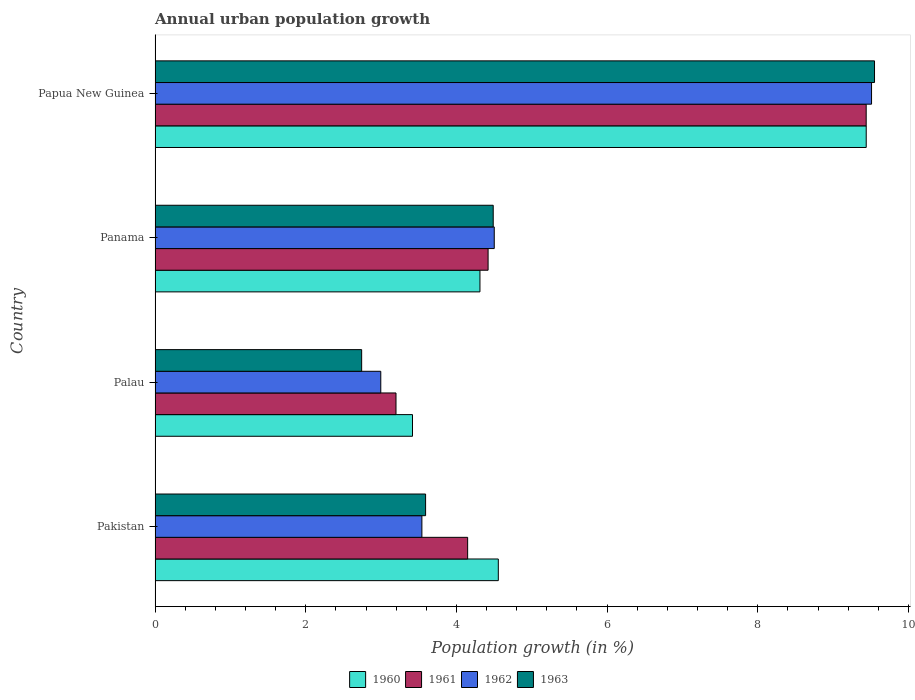What is the label of the 1st group of bars from the top?
Your response must be concise. Papua New Guinea. In how many cases, is the number of bars for a given country not equal to the number of legend labels?
Your answer should be compact. 0. What is the percentage of urban population growth in 1961 in Palau?
Make the answer very short. 3.2. Across all countries, what is the maximum percentage of urban population growth in 1960?
Provide a short and direct response. 9.44. Across all countries, what is the minimum percentage of urban population growth in 1961?
Make the answer very short. 3.2. In which country was the percentage of urban population growth in 1961 maximum?
Give a very brief answer. Papua New Guinea. In which country was the percentage of urban population growth in 1963 minimum?
Your answer should be compact. Palau. What is the total percentage of urban population growth in 1963 in the graph?
Offer a terse response. 20.37. What is the difference between the percentage of urban population growth in 1960 in Pakistan and that in Panama?
Offer a very short reply. 0.24. What is the difference between the percentage of urban population growth in 1962 in Papua New Guinea and the percentage of urban population growth in 1960 in Pakistan?
Your answer should be very brief. 4.95. What is the average percentage of urban population growth in 1961 per country?
Offer a very short reply. 5.3. What is the difference between the percentage of urban population growth in 1963 and percentage of urban population growth in 1961 in Palau?
Provide a succinct answer. -0.46. What is the ratio of the percentage of urban population growth in 1962 in Palau to that in Panama?
Keep it short and to the point. 0.67. Is the percentage of urban population growth in 1963 in Palau less than that in Papua New Guinea?
Keep it short and to the point. Yes. What is the difference between the highest and the second highest percentage of urban population growth in 1963?
Provide a short and direct response. 5.06. What is the difference between the highest and the lowest percentage of urban population growth in 1963?
Offer a terse response. 6.81. In how many countries, is the percentage of urban population growth in 1962 greater than the average percentage of urban population growth in 1962 taken over all countries?
Offer a very short reply. 1. Is the sum of the percentage of urban population growth in 1960 in Palau and Panama greater than the maximum percentage of urban population growth in 1962 across all countries?
Your answer should be very brief. No. Is it the case that in every country, the sum of the percentage of urban population growth in 1963 and percentage of urban population growth in 1961 is greater than the sum of percentage of urban population growth in 1960 and percentage of urban population growth in 1962?
Keep it short and to the point. No. What does the 1st bar from the top in Papua New Guinea represents?
Make the answer very short. 1963. What does the 2nd bar from the bottom in Papua New Guinea represents?
Your answer should be compact. 1961. How many countries are there in the graph?
Offer a terse response. 4. What is the difference between two consecutive major ticks on the X-axis?
Make the answer very short. 2. Are the values on the major ticks of X-axis written in scientific E-notation?
Keep it short and to the point. No. Does the graph contain any zero values?
Offer a very short reply. No. Does the graph contain grids?
Provide a succinct answer. No. How many legend labels are there?
Your answer should be very brief. 4. What is the title of the graph?
Offer a very short reply. Annual urban population growth. What is the label or title of the X-axis?
Make the answer very short. Population growth (in %). What is the label or title of the Y-axis?
Provide a short and direct response. Country. What is the Population growth (in %) in 1960 in Pakistan?
Provide a short and direct response. 4.56. What is the Population growth (in %) in 1961 in Pakistan?
Offer a very short reply. 4.15. What is the Population growth (in %) in 1962 in Pakistan?
Give a very brief answer. 3.54. What is the Population growth (in %) of 1963 in Pakistan?
Provide a short and direct response. 3.59. What is the Population growth (in %) of 1960 in Palau?
Give a very brief answer. 3.42. What is the Population growth (in %) of 1961 in Palau?
Make the answer very short. 3.2. What is the Population growth (in %) of 1962 in Palau?
Give a very brief answer. 3. What is the Population growth (in %) in 1963 in Palau?
Give a very brief answer. 2.74. What is the Population growth (in %) in 1960 in Panama?
Give a very brief answer. 4.31. What is the Population growth (in %) in 1961 in Panama?
Offer a very short reply. 4.42. What is the Population growth (in %) in 1962 in Panama?
Your answer should be very brief. 4.5. What is the Population growth (in %) in 1963 in Panama?
Your answer should be compact. 4.49. What is the Population growth (in %) of 1960 in Papua New Guinea?
Give a very brief answer. 9.44. What is the Population growth (in %) of 1961 in Papua New Guinea?
Your response must be concise. 9.44. What is the Population growth (in %) in 1962 in Papua New Guinea?
Your answer should be compact. 9.51. What is the Population growth (in %) in 1963 in Papua New Guinea?
Keep it short and to the point. 9.55. Across all countries, what is the maximum Population growth (in %) in 1960?
Your answer should be very brief. 9.44. Across all countries, what is the maximum Population growth (in %) in 1961?
Offer a terse response. 9.44. Across all countries, what is the maximum Population growth (in %) of 1962?
Offer a very short reply. 9.51. Across all countries, what is the maximum Population growth (in %) in 1963?
Your response must be concise. 9.55. Across all countries, what is the minimum Population growth (in %) of 1960?
Give a very brief answer. 3.42. Across all countries, what is the minimum Population growth (in %) of 1961?
Provide a short and direct response. 3.2. Across all countries, what is the minimum Population growth (in %) of 1962?
Give a very brief answer. 3. Across all countries, what is the minimum Population growth (in %) in 1963?
Your response must be concise. 2.74. What is the total Population growth (in %) of 1960 in the graph?
Give a very brief answer. 21.73. What is the total Population growth (in %) in 1961 in the graph?
Your response must be concise. 21.21. What is the total Population growth (in %) of 1962 in the graph?
Ensure brevity in your answer.  20.55. What is the total Population growth (in %) of 1963 in the graph?
Your response must be concise. 20.37. What is the difference between the Population growth (in %) in 1960 in Pakistan and that in Palau?
Ensure brevity in your answer.  1.14. What is the difference between the Population growth (in %) of 1961 in Pakistan and that in Palau?
Your response must be concise. 0.95. What is the difference between the Population growth (in %) of 1962 in Pakistan and that in Palau?
Your response must be concise. 0.55. What is the difference between the Population growth (in %) in 1963 in Pakistan and that in Palau?
Your response must be concise. 0.85. What is the difference between the Population growth (in %) in 1960 in Pakistan and that in Panama?
Ensure brevity in your answer.  0.24. What is the difference between the Population growth (in %) of 1961 in Pakistan and that in Panama?
Offer a very short reply. -0.27. What is the difference between the Population growth (in %) in 1962 in Pakistan and that in Panama?
Your answer should be compact. -0.96. What is the difference between the Population growth (in %) of 1963 in Pakistan and that in Panama?
Your answer should be very brief. -0.9. What is the difference between the Population growth (in %) in 1960 in Pakistan and that in Papua New Guinea?
Provide a short and direct response. -4.88. What is the difference between the Population growth (in %) in 1961 in Pakistan and that in Papua New Guinea?
Your answer should be compact. -5.29. What is the difference between the Population growth (in %) of 1962 in Pakistan and that in Papua New Guinea?
Your answer should be compact. -5.97. What is the difference between the Population growth (in %) in 1963 in Pakistan and that in Papua New Guinea?
Provide a short and direct response. -5.96. What is the difference between the Population growth (in %) of 1960 in Palau and that in Panama?
Ensure brevity in your answer.  -0.9. What is the difference between the Population growth (in %) in 1961 in Palau and that in Panama?
Offer a very short reply. -1.22. What is the difference between the Population growth (in %) of 1962 in Palau and that in Panama?
Your answer should be compact. -1.51. What is the difference between the Population growth (in %) in 1963 in Palau and that in Panama?
Provide a short and direct response. -1.75. What is the difference between the Population growth (in %) in 1960 in Palau and that in Papua New Guinea?
Ensure brevity in your answer.  -6.02. What is the difference between the Population growth (in %) of 1961 in Palau and that in Papua New Guinea?
Provide a succinct answer. -6.24. What is the difference between the Population growth (in %) in 1962 in Palau and that in Papua New Guinea?
Make the answer very short. -6.51. What is the difference between the Population growth (in %) of 1963 in Palau and that in Papua New Guinea?
Your answer should be very brief. -6.81. What is the difference between the Population growth (in %) of 1960 in Panama and that in Papua New Guinea?
Offer a terse response. -5.13. What is the difference between the Population growth (in %) of 1961 in Panama and that in Papua New Guinea?
Make the answer very short. -5.02. What is the difference between the Population growth (in %) in 1962 in Panama and that in Papua New Guinea?
Your answer should be very brief. -5.01. What is the difference between the Population growth (in %) of 1963 in Panama and that in Papua New Guinea?
Your response must be concise. -5.06. What is the difference between the Population growth (in %) of 1960 in Pakistan and the Population growth (in %) of 1961 in Palau?
Your response must be concise. 1.36. What is the difference between the Population growth (in %) in 1960 in Pakistan and the Population growth (in %) in 1962 in Palau?
Make the answer very short. 1.56. What is the difference between the Population growth (in %) in 1960 in Pakistan and the Population growth (in %) in 1963 in Palau?
Make the answer very short. 1.81. What is the difference between the Population growth (in %) of 1961 in Pakistan and the Population growth (in %) of 1962 in Palau?
Provide a short and direct response. 1.15. What is the difference between the Population growth (in %) in 1961 in Pakistan and the Population growth (in %) in 1963 in Palau?
Keep it short and to the point. 1.41. What is the difference between the Population growth (in %) in 1962 in Pakistan and the Population growth (in %) in 1963 in Palau?
Your answer should be compact. 0.8. What is the difference between the Population growth (in %) of 1960 in Pakistan and the Population growth (in %) of 1961 in Panama?
Offer a terse response. 0.14. What is the difference between the Population growth (in %) in 1960 in Pakistan and the Population growth (in %) in 1962 in Panama?
Your answer should be compact. 0.05. What is the difference between the Population growth (in %) in 1960 in Pakistan and the Population growth (in %) in 1963 in Panama?
Give a very brief answer. 0.07. What is the difference between the Population growth (in %) in 1961 in Pakistan and the Population growth (in %) in 1962 in Panama?
Offer a very short reply. -0.35. What is the difference between the Population growth (in %) in 1961 in Pakistan and the Population growth (in %) in 1963 in Panama?
Ensure brevity in your answer.  -0.34. What is the difference between the Population growth (in %) in 1962 in Pakistan and the Population growth (in %) in 1963 in Panama?
Offer a terse response. -0.95. What is the difference between the Population growth (in %) in 1960 in Pakistan and the Population growth (in %) in 1961 in Papua New Guinea?
Give a very brief answer. -4.88. What is the difference between the Population growth (in %) of 1960 in Pakistan and the Population growth (in %) of 1962 in Papua New Guinea?
Provide a succinct answer. -4.95. What is the difference between the Population growth (in %) of 1960 in Pakistan and the Population growth (in %) of 1963 in Papua New Guinea?
Make the answer very short. -4.99. What is the difference between the Population growth (in %) of 1961 in Pakistan and the Population growth (in %) of 1962 in Papua New Guinea?
Keep it short and to the point. -5.36. What is the difference between the Population growth (in %) in 1961 in Pakistan and the Population growth (in %) in 1963 in Papua New Guinea?
Offer a very short reply. -5.4. What is the difference between the Population growth (in %) of 1962 in Pakistan and the Population growth (in %) of 1963 in Papua New Guinea?
Ensure brevity in your answer.  -6.01. What is the difference between the Population growth (in %) of 1960 in Palau and the Population growth (in %) of 1961 in Panama?
Provide a succinct answer. -1. What is the difference between the Population growth (in %) in 1960 in Palau and the Population growth (in %) in 1962 in Panama?
Ensure brevity in your answer.  -1.09. What is the difference between the Population growth (in %) in 1960 in Palau and the Population growth (in %) in 1963 in Panama?
Your answer should be compact. -1.07. What is the difference between the Population growth (in %) of 1961 in Palau and the Population growth (in %) of 1962 in Panama?
Provide a succinct answer. -1.3. What is the difference between the Population growth (in %) in 1961 in Palau and the Population growth (in %) in 1963 in Panama?
Make the answer very short. -1.29. What is the difference between the Population growth (in %) in 1962 in Palau and the Population growth (in %) in 1963 in Panama?
Give a very brief answer. -1.49. What is the difference between the Population growth (in %) of 1960 in Palau and the Population growth (in %) of 1961 in Papua New Guinea?
Provide a short and direct response. -6.02. What is the difference between the Population growth (in %) in 1960 in Palau and the Population growth (in %) in 1962 in Papua New Guinea?
Offer a terse response. -6.09. What is the difference between the Population growth (in %) in 1960 in Palau and the Population growth (in %) in 1963 in Papua New Guinea?
Provide a succinct answer. -6.13. What is the difference between the Population growth (in %) in 1961 in Palau and the Population growth (in %) in 1962 in Papua New Guinea?
Your answer should be very brief. -6.31. What is the difference between the Population growth (in %) in 1961 in Palau and the Population growth (in %) in 1963 in Papua New Guinea?
Ensure brevity in your answer.  -6.35. What is the difference between the Population growth (in %) in 1962 in Palau and the Population growth (in %) in 1963 in Papua New Guinea?
Keep it short and to the point. -6.55. What is the difference between the Population growth (in %) in 1960 in Panama and the Population growth (in %) in 1961 in Papua New Guinea?
Your answer should be very brief. -5.13. What is the difference between the Population growth (in %) of 1960 in Panama and the Population growth (in %) of 1962 in Papua New Guinea?
Provide a succinct answer. -5.2. What is the difference between the Population growth (in %) of 1960 in Panama and the Population growth (in %) of 1963 in Papua New Guinea?
Keep it short and to the point. -5.24. What is the difference between the Population growth (in %) of 1961 in Panama and the Population growth (in %) of 1962 in Papua New Guinea?
Offer a terse response. -5.09. What is the difference between the Population growth (in %) in 1961 in Panama and the Population growth (in %) in 1963 in Papua New Guinea?
Provide a succinct answer. -5.13. What is the difference between the Population growth (in %) in 1962 in Panama and the Population growth (in %) in 1963 in Papua New Guinea?
Your response must be concise. -5.05. What is the average Population growth (in %) of 1960 per country?
Your answer should be compact. 5.43. What is the average Population growth (in %) of 1961 per country?
Give a very brief answer. 5.3. What is the average Population growth (in %) of 1962 per country?
Provide a succinct answer. 5.14. What is the average Population growth (in %) of 1963 per country?
Ensure brevity in your answer.  5.09. What is the difference between the Population growth (in %) of 1960 and Population growth (in %) of 1961 in Pakistan?
Keep it short and to the point. 0.41. What is the difference between the Population growth (in %) in 1960 and Population growth (in %) in 1962 in Pakistan?
Ensure brevity in your answer.  1.01. What is the difference between the Population growth (in %) of 1960 and Population growth (in %) of 1963 in Pakistan?
Offer a terse response. 0.97. What is the difference between the Population growth (in %) of 1961 and Population growth (in %) of 1962 in Pakistan?
Offer a terse response. 0.61. What is the difference between the Population growth (in %) of 1961 and Population growth (in %) of 1963 in Pakistan?
Offer a very short reply. 0.56. What is the difference between the Population growth (in %) of 1962 and Population growth (in %) of 1963 in Pakistan?
Offer a terse response. -0.05. What is the difference between the Population growth (in %) in 1960 and Population growth (in %) in 1961 in Palau?
Offer a very short reply. 0.22. What is the difference between the Population growth (in %) in 1960 and Population growth (in %) in 1962 in Palau?
Provide a short and direct response. 0.42. What is the difference between the Population growth (in %) of 1960 and Population growth (in %) of 1963 in Palau?
Make the answer very short. 0.68. What is the difference between the Population growth (in %) of 1961 and Population growth (in %) of 1962 in Palau?
Provide a short and direct response. 0.2. What is the difference between the Population growth (in %) of 1961 and Population growth (in %) of 1963 in Palau?
Your response must be concise. 0.46. What is the difference between the Population growth (in %) of 1962 and Population growth (in %) of 1963 in Palau?
Offer a very short reply. 0.25. What is the difference between the Population growth (in %) in 1960 and Population growth (in %) in 1961 in Panama?
Ensure brevity in your answer.  -0.11. What is the difference between the Population growth (in %) of 1960 and Population growth (in %) of 1962 in Panama?
Provide a succinct answer. -0.19. What is the difference between the Population growth (in %) of 1960 and Population growth (in %) of 1963 in Panama?
Make the answer very short. -0.18. What is the difference between the Population growth (in %) of 1961 and Population growth (in %) of 1962 in Panama?
Offer a very short reply. -0.08. What is the difference between the Population growth (in %) of 1961 and Population growth (in %) of 1963 in Panama?
Offer a very short reply. -0.07. What is the difference between the Population growth (in %) of 1962 and Population growth (in %) of 1963 in Panama?
Provide a succinct answer. 0.01. What is the difference between the Population growth (in %) of 1960 and Population growth (in %) of 1961 in Papua New Guinea?
Your response must be concise. 0. What is the difference between the Population growth (in %) in 1960 and Population growth (in %) in 1962 in Papua New Guinea?
Ensure brevity in your answer.  -0.07. What is the difference between the Population growth (in %) in 1960 and Population growth (in %) in 1963 in Papua New Guinea?
Your answer should be compact. -0.11. What is the difference between the Population growth (in %) in 1961 and Population growth (in %) in 1962 in Papua New Guinea?
Give a very brief answer. -0.07. What is the difference between the Population growth (in %) in 1961 and Population growth (in %) in 1963 in Papua New Guinea?
Offer a very short reply. -0.11. What is the difference between the Population growth (in %) of 1962 and Population growth (in %) of 1963 in Papua New Guinea?
Your answer should be compact. -0.04. What is the ratio of the Population growth (in %) in 1960 in Pakistan to that in Palau?
Provide a short and direct response. 1.33. What is the ratio of the Population growth (in %) in 1961 in Pakistan to that in Palau?
Your answer should be compact. 1.3. What is the ratio of the Population growth (in %) of 1962 in Pakistan to that in Palau?
Make the answer very short. 1.18. What is the ratio of the Population growth (in %) of 1963 in Pakistan to that in Palau?
Provide a succinct answer. 1.31. What is the ratio of the Population growth (in %) in 1960 in Pakistan to that in Panama?
Your response must be concise. 1.06. What is the ratio of the Population growth (in %) of 1961 in Pakistan to that in Panama?
Give a very brief answer. 0.94. What is the ratio of the Population growth (in %) in 1962 in Pakistan to that in Panama?
Your response must be concise. 0.79. What is the ratio of the Population growth (in %) of 1963 in Pakistan to that in Panama?
Ensure brevity in your answer.  0.8. What is the ratio of the Population growth (in %) in 1960 in Pakistan to that in Papua New Guinea?
Your answer should be very brief. 0.48. What is the ratio of the Population growth (in %) in 1961 in Pakistan to that in Papua New Guinea?
Keep it short and to the point. 0.44. What is the ratio of the Population growth (in %) in 1962 in Pakistan to that in Papua New Guinea?
Offer a terse response. 0.37. What is the ratio of the Population growth (in %) of 1963 in Pakistan to that in Papua New Guinea?
Offer a very short reply. 0.38. What is the ratio of the Population growth (in %) of 1960 in Palau to that in Panama?
Ensure brevity in your answer.  0.79. What is the ratio of the Population growth (in %) in 1961 in Palau to that in Panama?
Make the answer very short. 0.72. What is the ratio of the Population growth (in %) of 1962 in Palau to that in Panama?
Your response must be concise. 0.67. What is the ratio of the Population growth (in %) in 1963 in Palau to that in Panama?
Your answer should be very brief. 0.61. What is the ratio of the Population growth (in %) of 1960 in Palau to that in Papua New Guinea?
Provide a short and direct response. 0.36. What is the ratio of the Population growth (in %) of 1961 in Palau to that in Papua New Guinea?
Provide a succinct answer. 0.34. What is the ratio of the Population growth (in %) of 1962 in Palau to that in Papua New Guinea?
Your answer should be compact. 0.32. What is the ratio of the Population growth (in %) in 1963 in Palau to that in Papua New Guinea?
Your answer should be very brief. 0.29. What is the ratio of the Population growth (in %) in 1960 in Panama to that in Papua New Guinea?
Offer a terse response. 0.46. What is the ratio of the Population growth (in %) of 1961 in Panama to that in Papua New Guinea?
Offer a terse response. 0.47. What is the ratio of the Population growth (in %) in 1962 in Panama to that in Papua New Guinea?
Your answer should be very brief. 0.47. What is the ratio of the Population growth (in %) of 1963 in Panama to that in Papua New Guinea?
Your answer should be compact. 0.47. What is the difference between the highest and the second highest Population growth (in %) of 1960?
Give a very brief answer. 4.88. What is the difference between the highest and the second highest Population growth (in %) in 1961?
Ensure brevity in your answer.  5.02. What is the difference between the highest and the second highest Population growth (in %) of 1962?
Your answer should be very brief. 5.01. What is the difference between the highest and the second highest Population growth (in %) of 1963?
Provide a short and direct response. 5.06. What is the difference between the highest and the lowest Population growth (in %) of 1960?
Give a very brief answer. 6.02. What is the difference between the highest and the lowest Population growth (in %) of 1961?
Provide a short and direct response. 6.24. What is the difference between the highest and the lowest Population growth (in %) in 1962?
Your answer should be very brief. 6.51. What is the difference between the highest and the lowest Population growth (in %) of 1963?
Give a very brief answer. 6.81. 